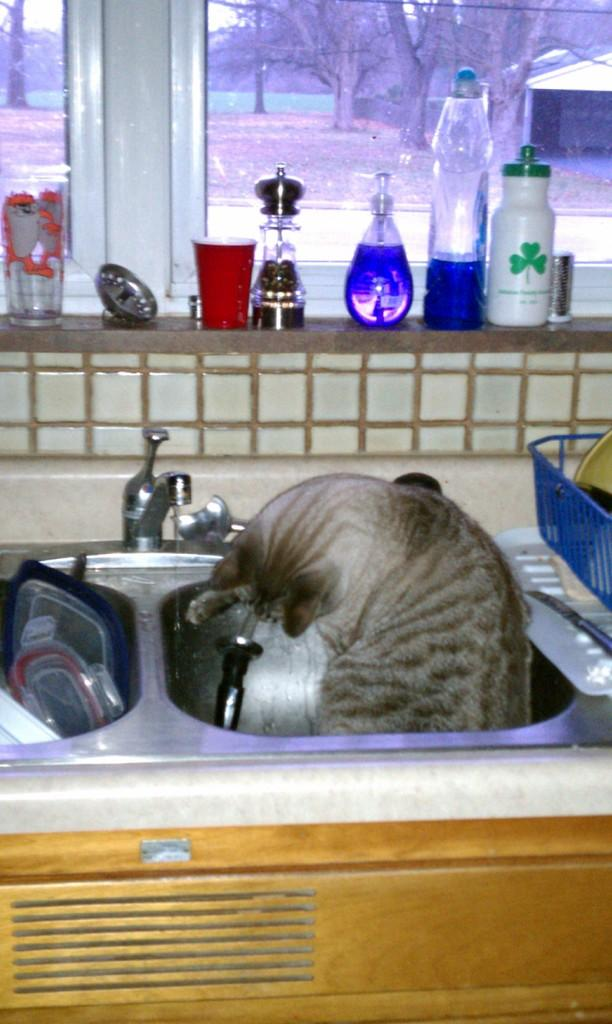What is in the sink in the image? There is a cat in the sink in the image. What other objects can be seen in the image? There are bottles in the image. Where is the window located in the image? There is a window in the image. What can be seen through the window? Trees are visible through the window. What type of knot is the cat using to secure the mine in the image? There is no knot or mine present in the image; it features a cat in a sink and bottles. 